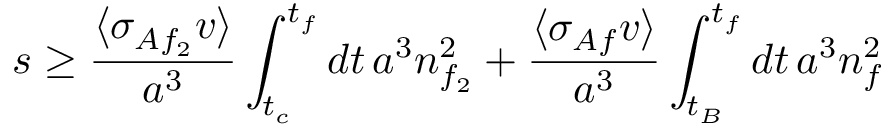<formula> <loc_0><loc_0><loc_500><loc_500>s \geq \frac { \langle \sigma _ { A f _ { 2 } } v \rangle } { a ^ { 3 } } \int _ { t _ { c } } ^ { t _ { f } } d t \, a ^ { 3 } n _ { f _ { 2 } } ^ { 2 } + \frac { \langle \sigma _ { A f } v \rangle } { a ^ { 3 } } \int _ { t _ { B } } ^ { t _ { f } } d t \, a ^ { 3 } n _ { f } ^ { 2 }</formula> 